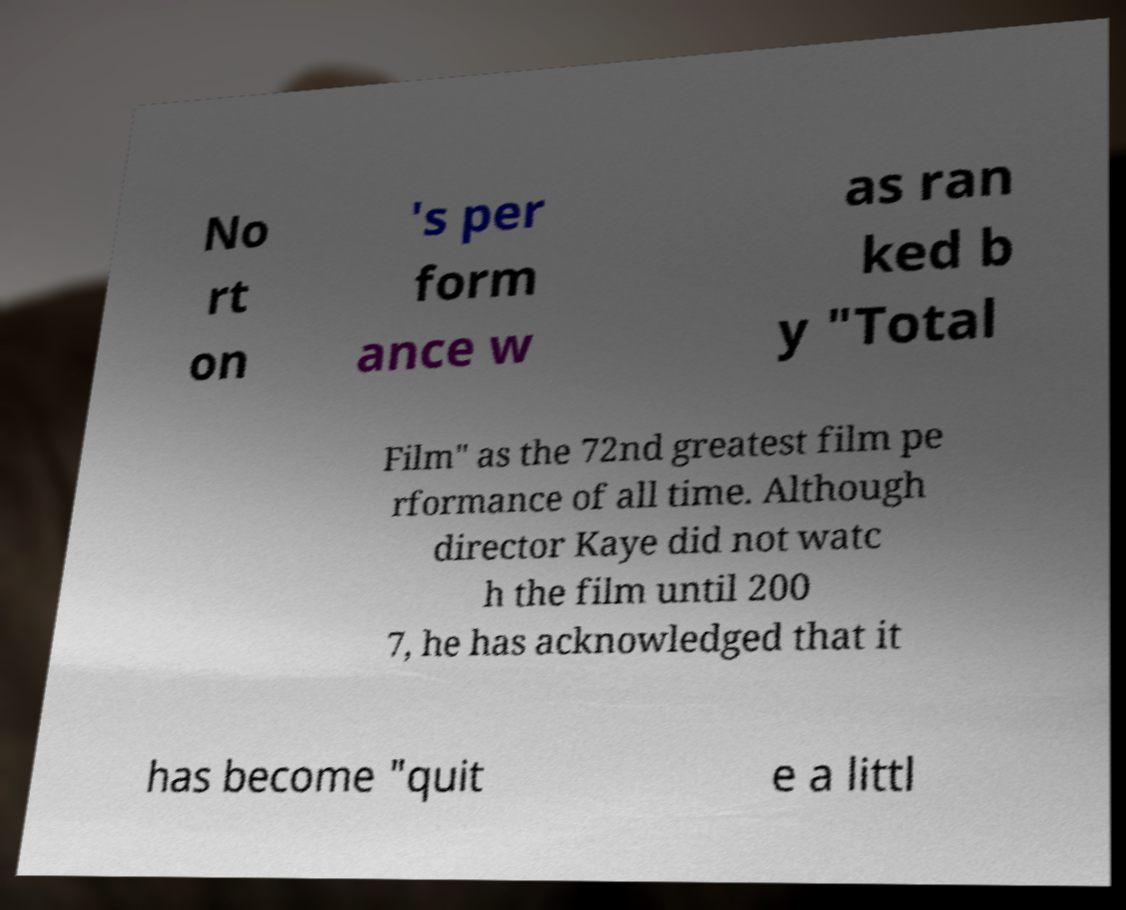Please read and relay the text visible in this image. What does it say? No rt on 's per form ance w as ran ked b y "Total Film" as the 72nd greatest film pe rformance of all time. Although director Kaye did not watc h the film until 200 7, he has acknowledged that it has become "quit e a littl 